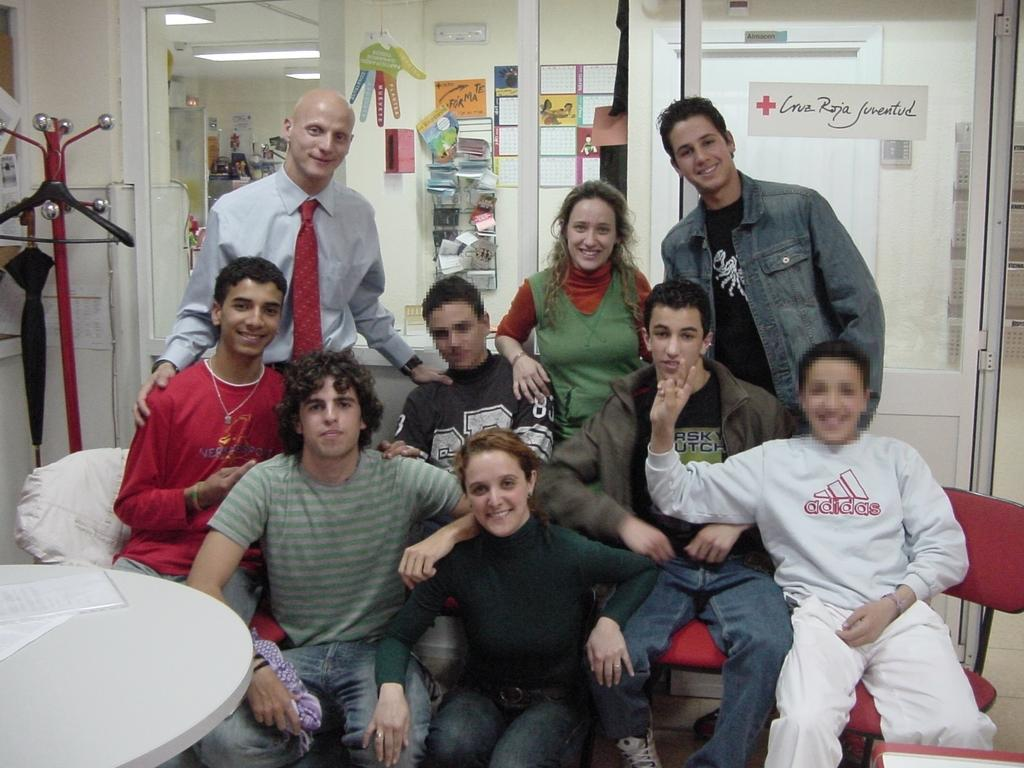What is happening in the image involving a group of people? There is a group of people in the image, and they are sitting. What might be the purpose of the people sitting in the image? The people are posing for a photo. What type of verse is being recited by the people in the image? There is no indication in the image that the people are reciting any verse. 